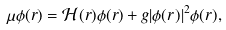<formula> <loc_0><loc_0><loc_500><loc_500>\mu \phi ( r ) = \mathcal { H } ( r ) \phi ( r ) + g | \phi ( r ) | ^ { 2 } \phi ( r ) ,</formula> 